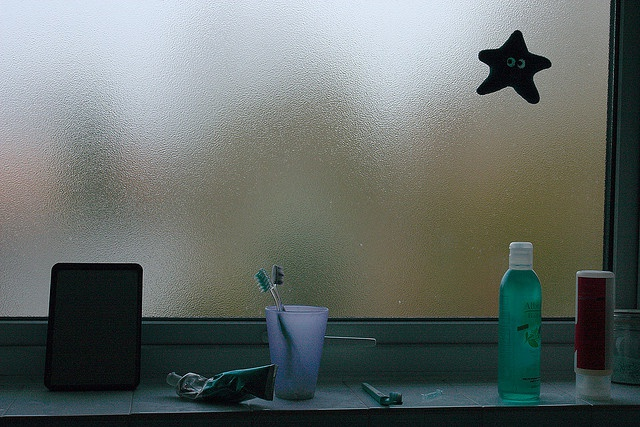Describe the objects in this image and their specific colors. I can see bottle in lavender, teal, darkgreen, black, and gray tones, bottle in lavender, black, purple, teal, and darkgreen tones, cup in lavender, blue, gray, and darkblue tones, toothbrush in lavender, black, teal, gray, and darkblue tones, and toothbrush in lavender, gray, teal, black, and darkgreen tones in this image. 